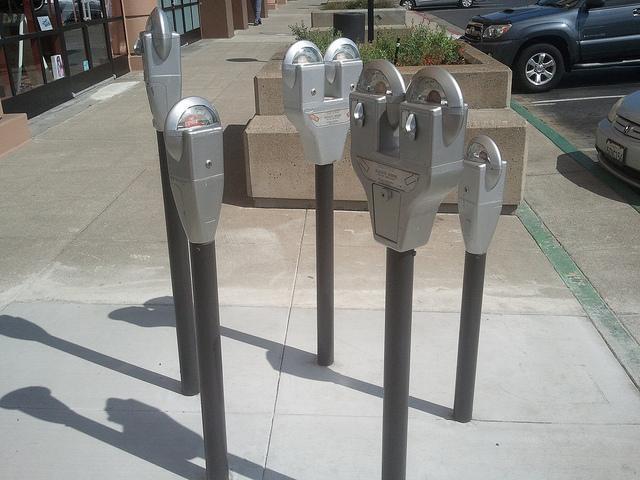How many parking meters are there?
Give a very brief answer. 5. How many parking meters are shown?
Give a very brief answer. 5. How many parking meters are in the picture?
Give a very brief answer. 5. How many cars are there?
Give a very brief answer. 2. How many people are riding horses?
Give a very brief answer. 0. 